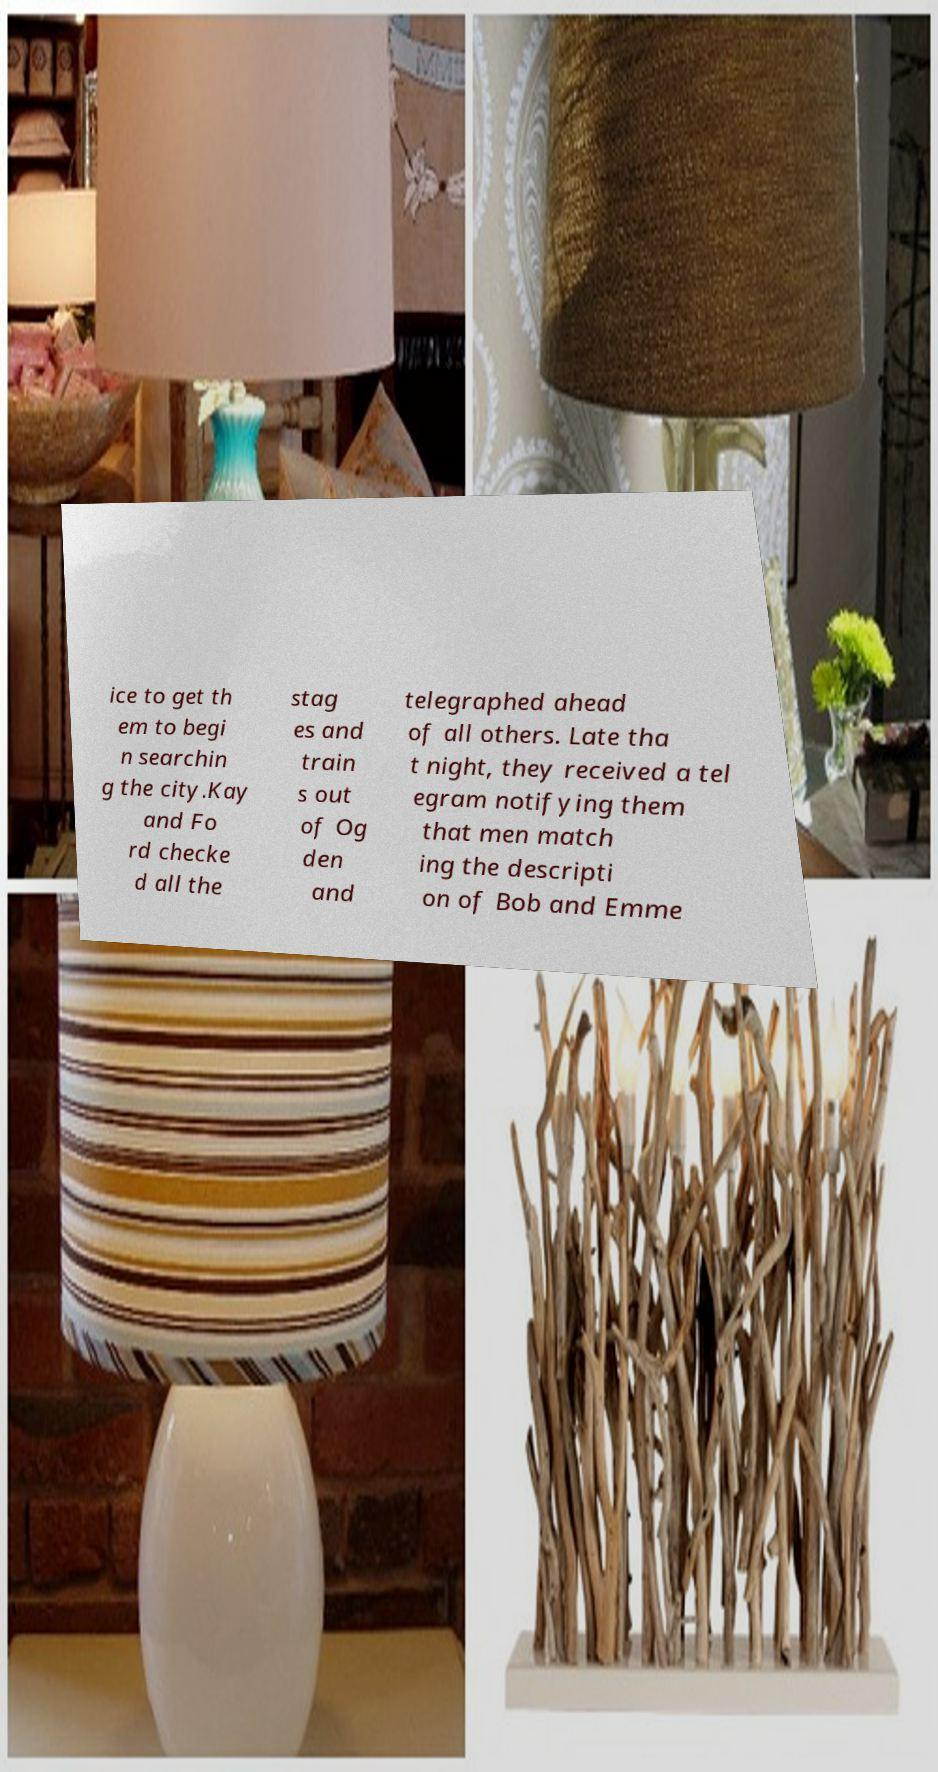I need the written content from this picture converted into text. Can you do that? ice to get th em to begi n searchin g the city.Kay and Fo rd checke d all the stag es and train s out of Og den and telegraphed ahead of all others. Late tha t night, they received a tel egram notifying them that men match ing the descripti on of Bob and Emme 